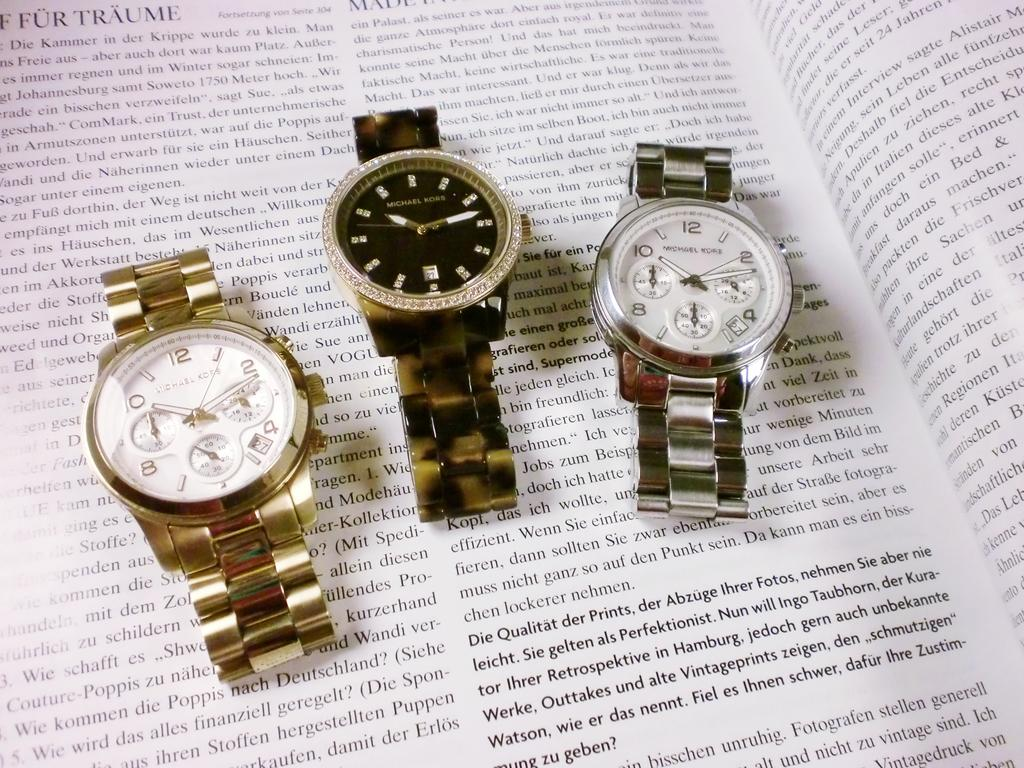<image>
Write a terse but informative summary of the picture. Three Michael Kors watches are sitting on top of a page of text. 